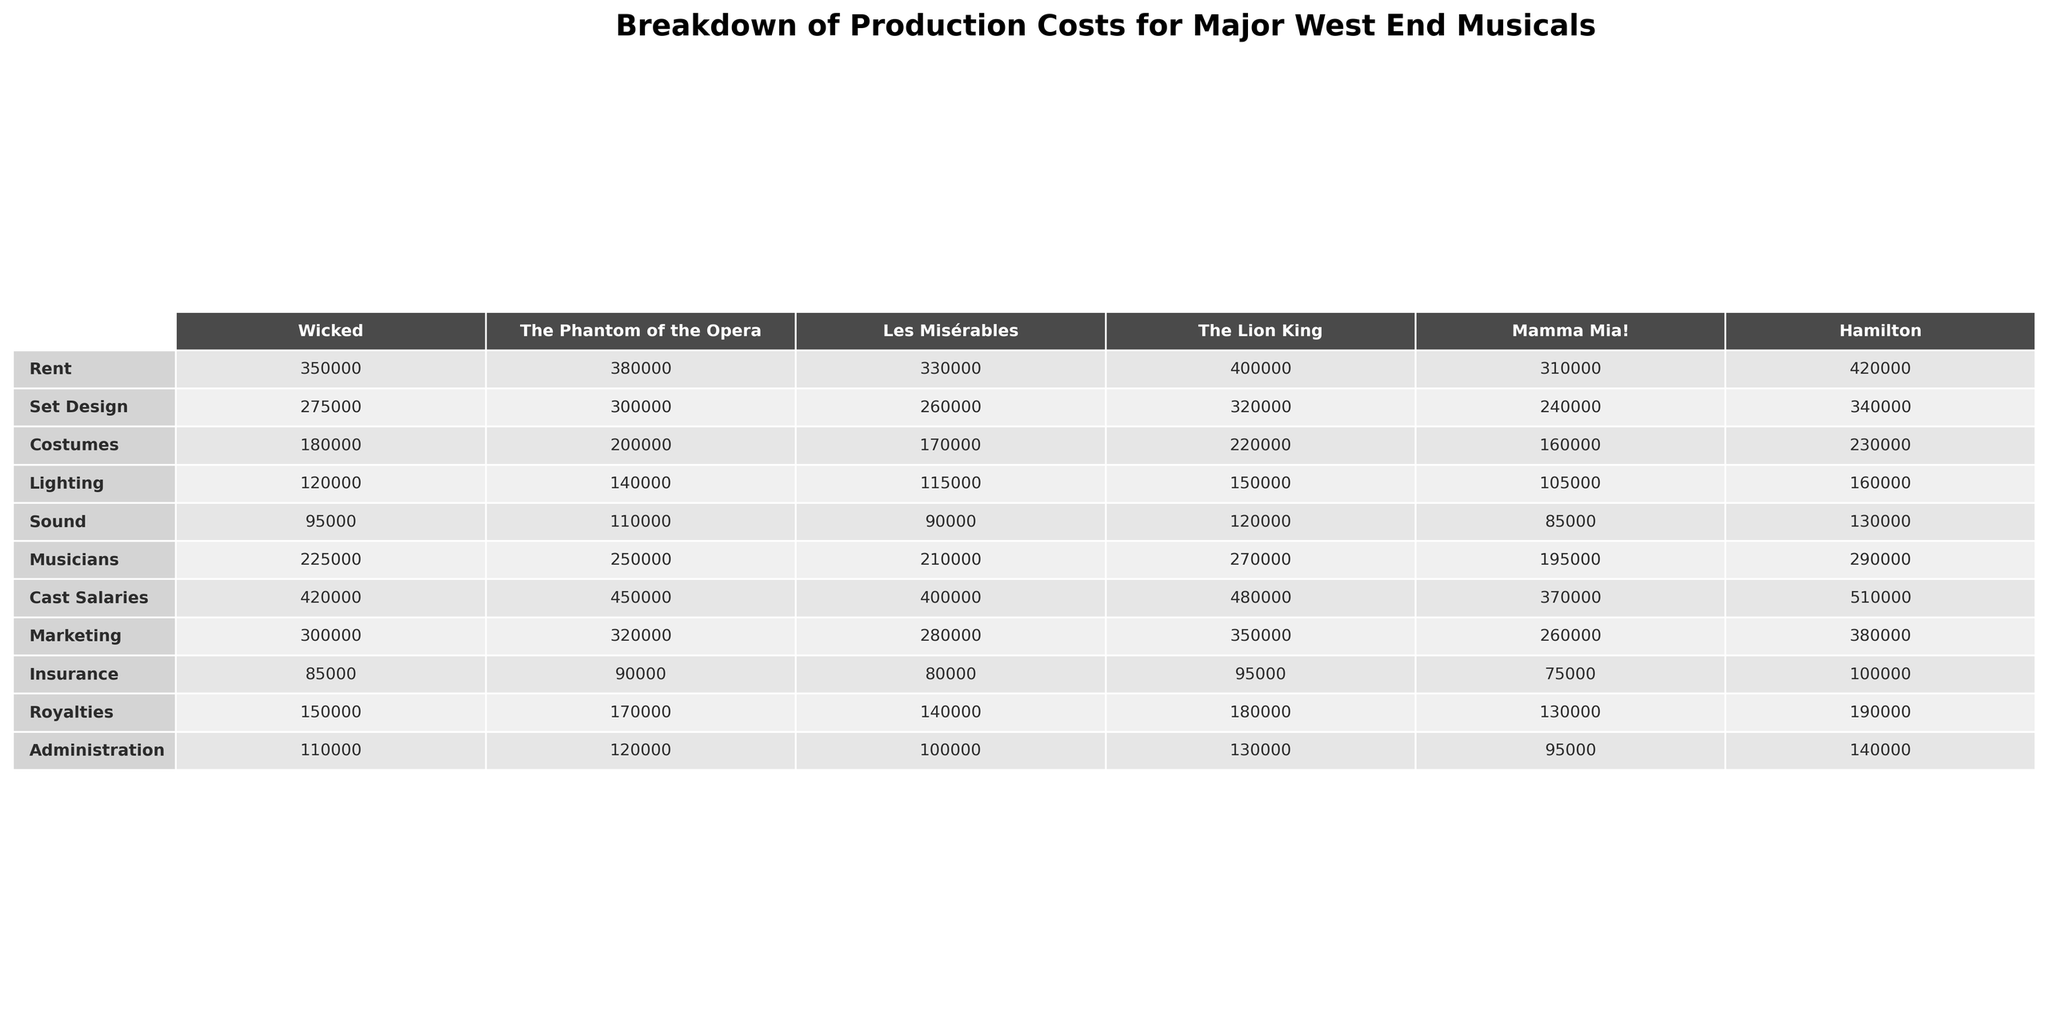What is the highest rent among the musicals? By examining the Rent column in the table, "Hamilton" has the highest rent at 420,000.
Answer: 420,000 What is the total cost of Set Design for "The Lion King"? The Set Design cost for "The Lion King" is 320,000 as stated in the table.
Answer: 320,000 Which musical has the lowest cost for Marketing? Looking at the Marketing column, "Mamma Mia!" has the lowest cost for Marketing at 260,000.
Answer: Mamma Mia! What is the combined total of Cast Salaries and Musicians for "Wicked"? The Cast Salaries for "Wicked" is 420,000 and Musicians is 225,000. Adding them gives 420,000 + 225,000 = 645,000.
Answer: 645,000 Do both "Les Misérables" and "Mamma Mia!" have the same amount spent on Insurance? For "Les Misérables," the Insurance cost is 80,000, while for "Mamma Mia!" it is 75,000. Since 80,000 does not equal 75,000, the statement is false.
Answer: No Which musical spends the most in total across all categories? Summing the expenses for each musical: "Hamilton" totals to 2,050,000, "The Lion King" totals to 2,030,000, "Wicked" totals to 1,920,000, "The Phantom of the Opera" totals to 2,030,000, "Les Misérables" totals to 1,760,000, and "Mamma Mia!" totals to 1,570,000. Since 2,050,000 is the highest, it belongs to "Hamilton".
Answer: Hamilton What is the average cost spent on Lighting across all musicals? To find the average, add the Lighting costs: (120000 + 140000 + 115000 + 150000 + 105000 + 160000) = 890000. Then divide by 6 (the number of musicals): 890000 / 6 = 148333.33, which rounds down to 148,333 when presented in whole numbers.
Answer: 148,333 Does "The Phantom of the Opera" have a higher Insurance cost than "Les Misérables"? From the table, the Insurance cost for "The Phantom of the Opera" is 90,000 and for "Les Misérables", it is 80,000. Since 90,000 > 80,000, the statement is true.
Answer: Yes What is the difference in total costs between "Hamilton" and "Mamma Mia!"? The total cost for "Hamilton" is 2,050,000 and for "Mamma Mia!" it is 1,570,000. The difference is 2,050,000 - 1,570,000 = 480,000.
Answer: 480,000 Which category does "The Lion King" allocate the most resources to? Looking at the table, "The Lion King" allocates the most resources to Cast Salaries, which is 480,000.
Answer: Cast Salaries Is the total cost of Sound for "Wicked" greater than the total cost of Costumes for "The Lion King"? The Sound cost for "Wicked" is 95,000 and the Costumes for "The Lion King" is 220,000. Since 95,000 < 220,000, the statement is false.
Answer: No 